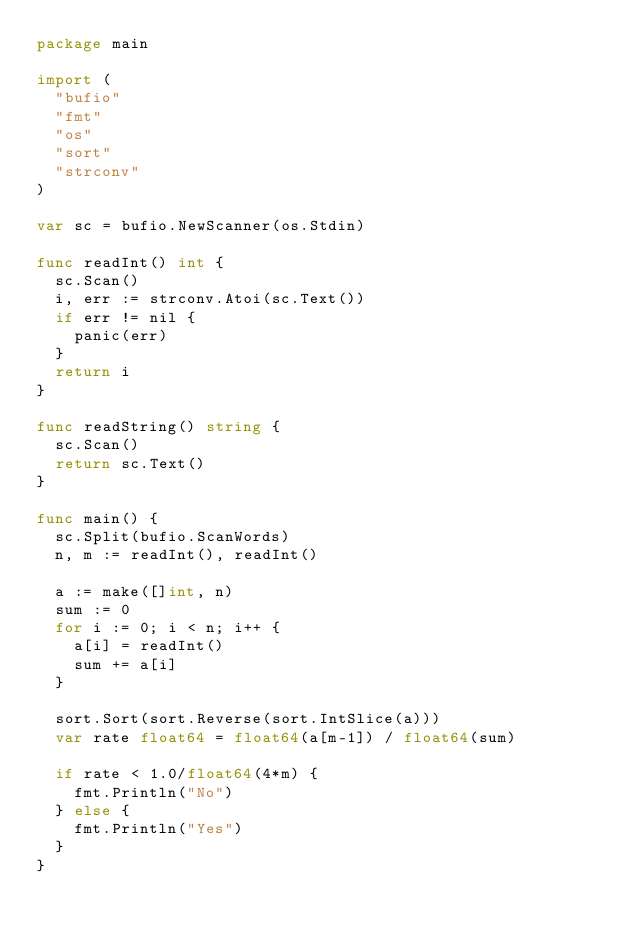Convert code to text. <code><loc_0><loc_0><loc_500><loc_500><_Go_>package main

import (
	"bufio"
	"fmt"
	"os"
	"sort"
	"strconv"
)

var sc = bufio.NewScanner(os.Stdin)

func readInt() int {
	sc.Scan()
	i, err := strconv.Atoi(sc.Text())
	if err != nil {
		panic(err)
	}
	return i
}

func readString() string {
	sc.Scan()
	return sc.Text()
}

func main() {
	sc.Split(bufio.ScanWords)
	n, m := readInt(), readInt()

	a := make([]int, n)
	sum := 0
	for i := 0; i < n; i++ {
		a[i] = readInt()
		sum += a[i]
	}

	sort.Sort(sort.Reverse(sort.IntSlice(a)))
	var rate float64 = float64(a[m-1]) / float64(sum)

	if rate < 1.0/float64(4*m) {
		fmt.Println("No")
	} else {
		fmt.Println("Yes")
	}
}
</code> 